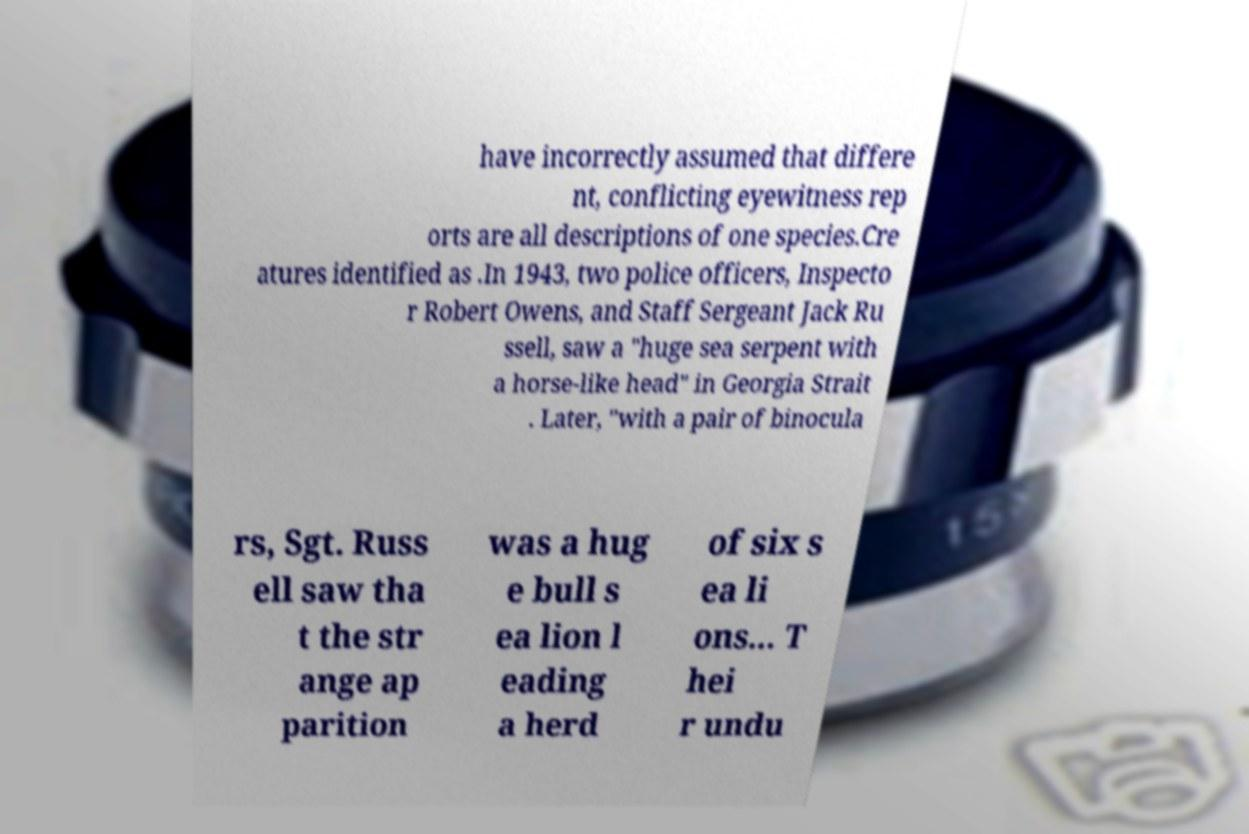Please read and relay the text visible in this image. What does it say? have incorrectly assumed that differe nt, conflicting eyewitness rep orts are all descriptions of one species.Cre atures identified as .In 1943, two police officers, Inspecto r Robert Owens, and Staff Sergeant Jack Ru ssell, saw a "huge sea serpent with a horse-like head" in Georgia Strait . Later, "with a pair of binocula rs, Sgt. Russ ell saw tha t the str ange ap parition was a hug e bull s ea lion l eading a herd of six s ea li ons... T hei r undu 